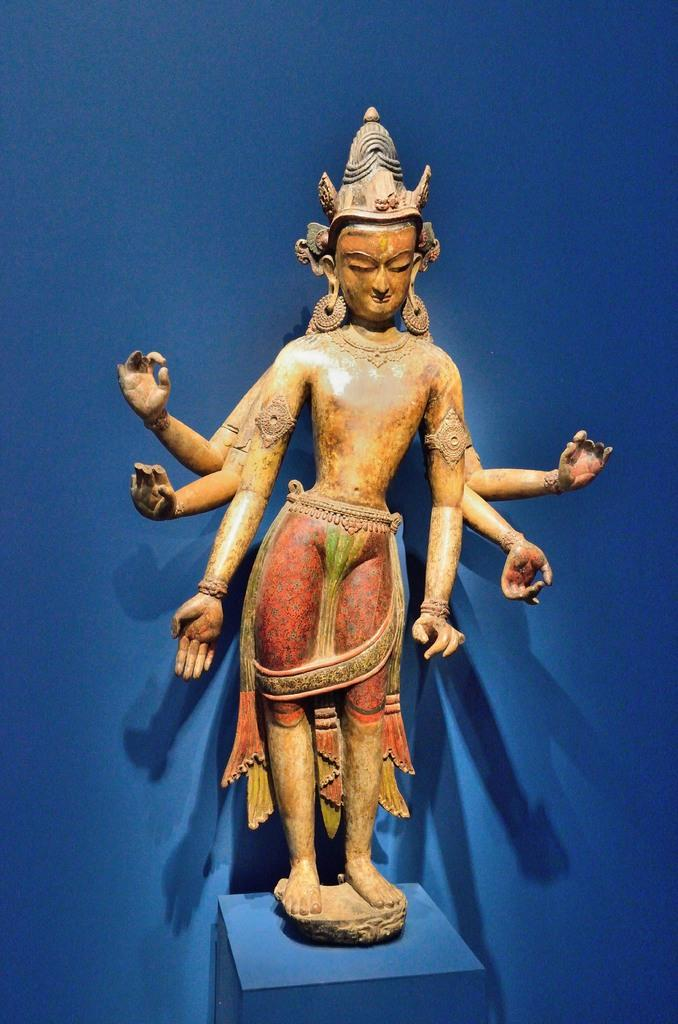What is the main subject of the image? There is a sculpture in the image. Where is the sculpture placed? The sculpture is on a stool. What is the color of the stool? The stool is blue in color. What type of toy can be seen swimming in the image? There is no toy or swimming activity depicted in the image; it features a sculpture on a blue stool. 